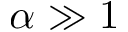Convert formula to latex. <formula><loc_0><loc_0><loc_500><loc_500>\alpha \gg 1</formula> 